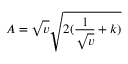Convert formula to latex. <formula><loc_0><loc_0><loc_500><loc_500>A = \sqrt { v } \sqrt { 2 ( \frac { 1 } { \sqrt { v } } + k ) }</formula> 